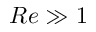<formula> <loc_0><loc_0><loc_500><loc_500>R e \gg 1</formula> 